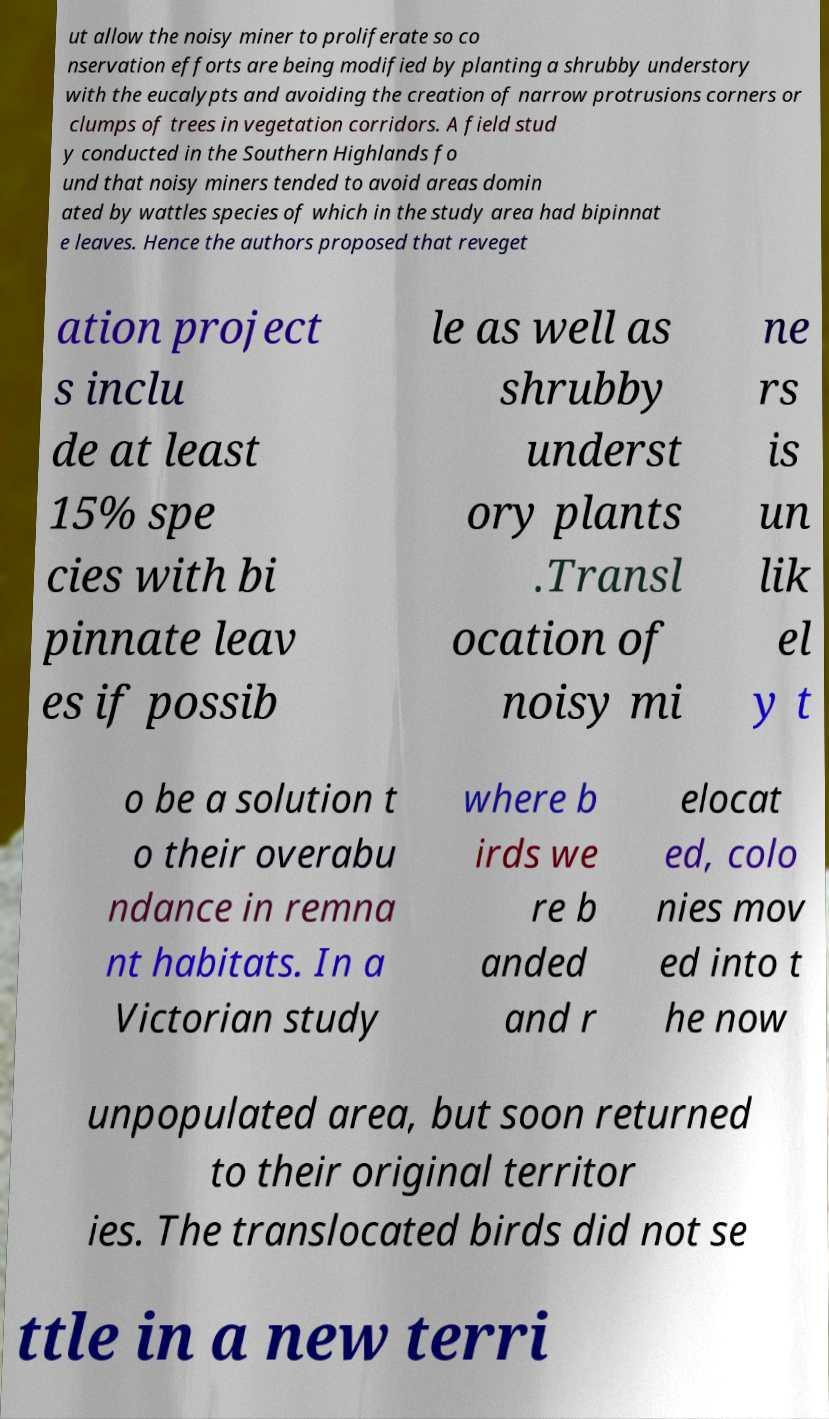Can you read and provide the text displayed in the image?This photo seems to have some interesting text. Can you extract and type it out for me? ut allow the noisy miner to proliferate so co nservation efforts are being modified by planting a shrubby understory with the eucalypts and avoiding the creation of narrow protrusions corners or clumps of trees in vegetation corridors. A field stud y conducted in the Southern Highlands fo und that noisy miners tended to avoid areas domin ated by wattles species of which in the study area had bipinnat e leaves. Hence the authors proposed that reveget ation project s inclu de at least 15% spe cies with bi pinnate leav es if possib le as well as shrubby underst ory plants .Transl ocation of noisy mi ne rs is un lik el y t o be a solution t o their overabu ndance in remna nt habitats. In a Victorian study where b irds we re b anded and r elocat ed, colo nies mov ed into t he now unpopulated area, but soon returned to their original territor ies. The translocated birds did not se ttle in a new terri 